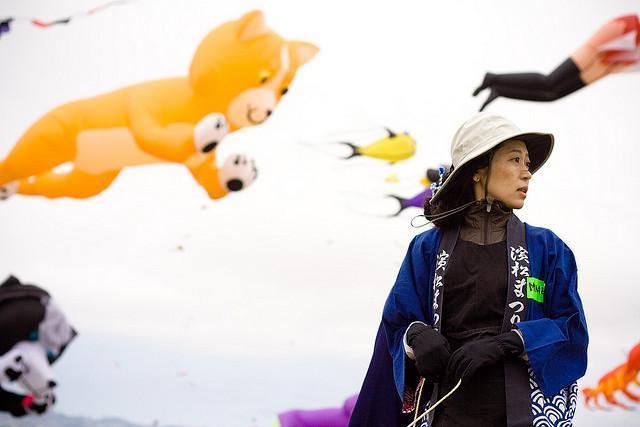How many kites are there?
Give a very brief answer. 3. 